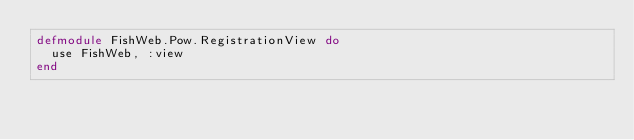Convert code to text. <code><loc_0><loc_0><loc_500><loc_500><_Elixir_>defmodule FishWeb.Pow.RegistrationView do
  use FishWeb, :view
end
</code> 